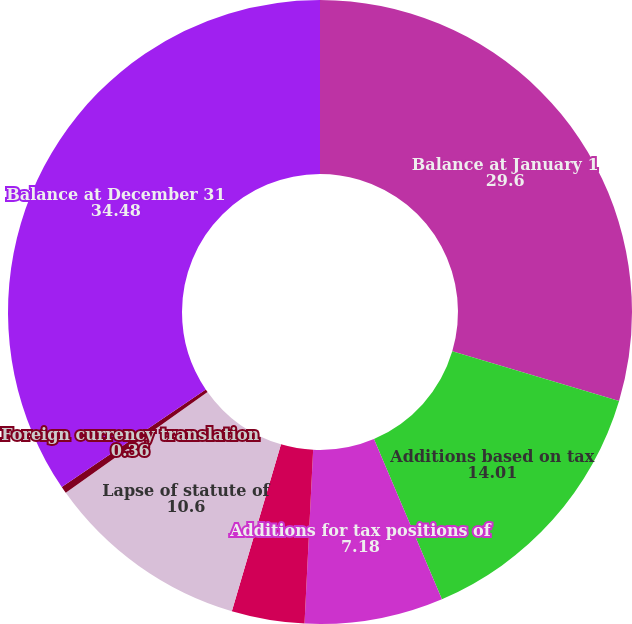Convert chart to OTSL. <chart><loc_0><loc_0><loc_500><loc_500><pie_chart><fcel>Balance at January 1<fcel>Additions based on tax<fcel>Additions for tax positions of<fcel>Reductions for tax positions<fcel>Lapse of statute of<fcel>Foreign currency translation<fcel>Balance at December 31<nl><fcel>29.6%<fcel>14.01%<fcel>7.18%<fcel>3.77%<fcel>10.6%<fcel>0.36%<fcel>34.48%<nl></chart> 